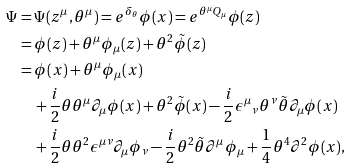<formula> <loc_0><loc_0><loc_500><loc_500>\Psi & = \Psi ( z ^ { \mu } , \theta ^ { \mu } ) = e ^ { \delta _ { \theta } } \phi ( x ) = e ^ { \theta ^ { \mu } Q _ { \mu } } \phi ( z ) \\ & = \phi ( z ) + \theta ^ { \mu } \phi _ { \mu } ( z ) + \theta ^ { 2 } \tilde { \phi } ( z ) \\ & = \phi ( x ) + \theta ^ { \mu } \phi _ { \mu } ( x ) \\ & \quad + \frac { i } { 2 } \theta \theta ^ { \mu } \partial _ { \mu } \phi ( x ) + \theta ^ { 2 } \tilde { \phi } ( x ) - \frac { i } { 2 } \epsilon ^ { \mu } { _ { \nu } } \theta ^ { \nu } \tilde { \theta } \partial _ { \mu } \phi ( x ) \\ & \quad + \frac { i } { 2 } \theta \theta ^ { 2 } \epsilon ^ { \mu \nu } \partial _ { \mu } \phi _ { \nu } - \frac { i } { 2 } \theta ^ { 2 } \tilde { \theta } \partial ^ { \mu } \phi _ { \mu } + \frac { 1 } { 4 } \theta ^ { 4 } \partial ^ { 2 } \phi ( x ) ,</formula> 